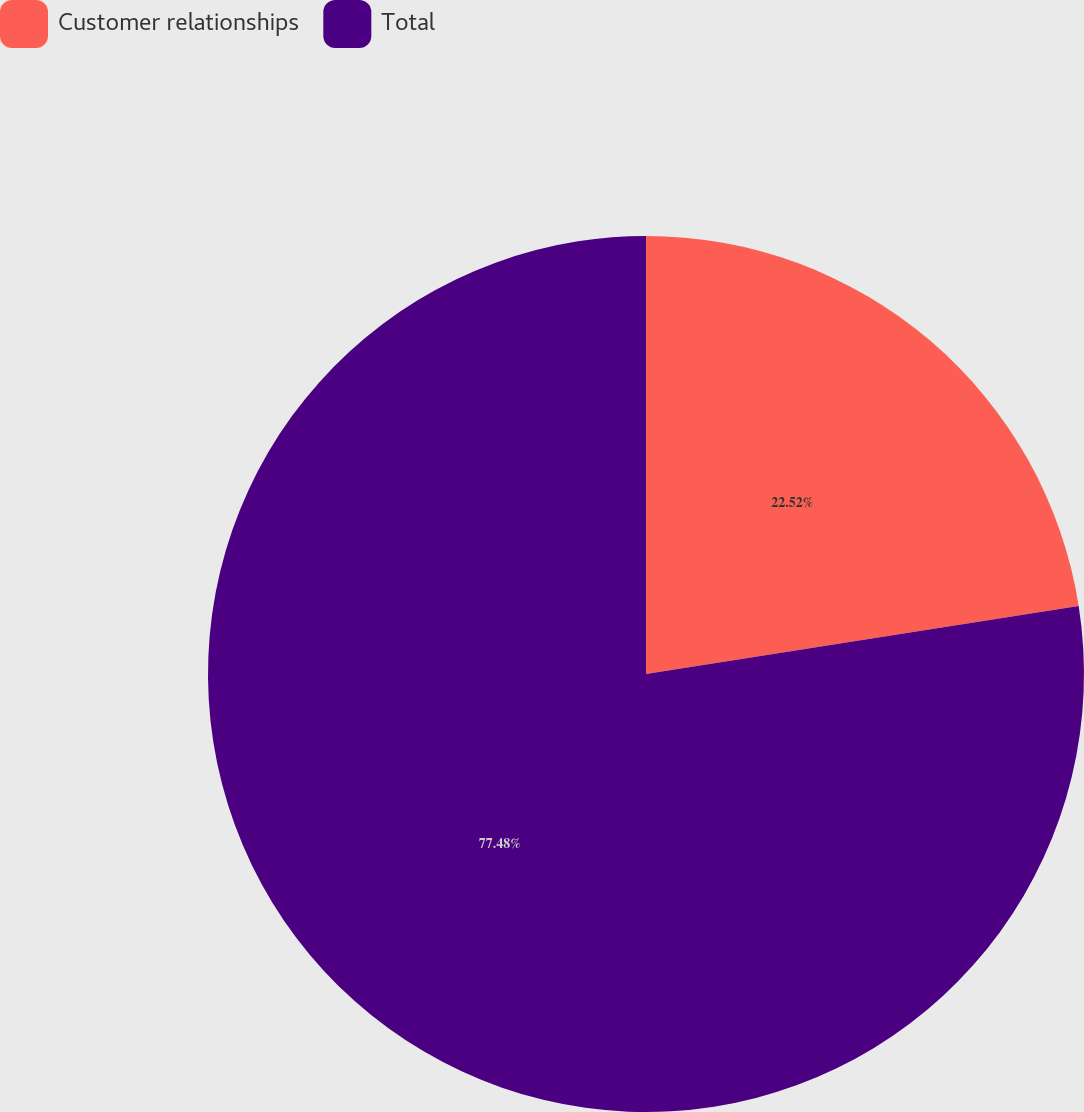<chart> <loc_0><loc_0><loc_500><loc_500><pie_chart><fcel>Customer relationships<fcel>Total<nl><fcel>22.52%<fcel>77.48%<nl></chart> 